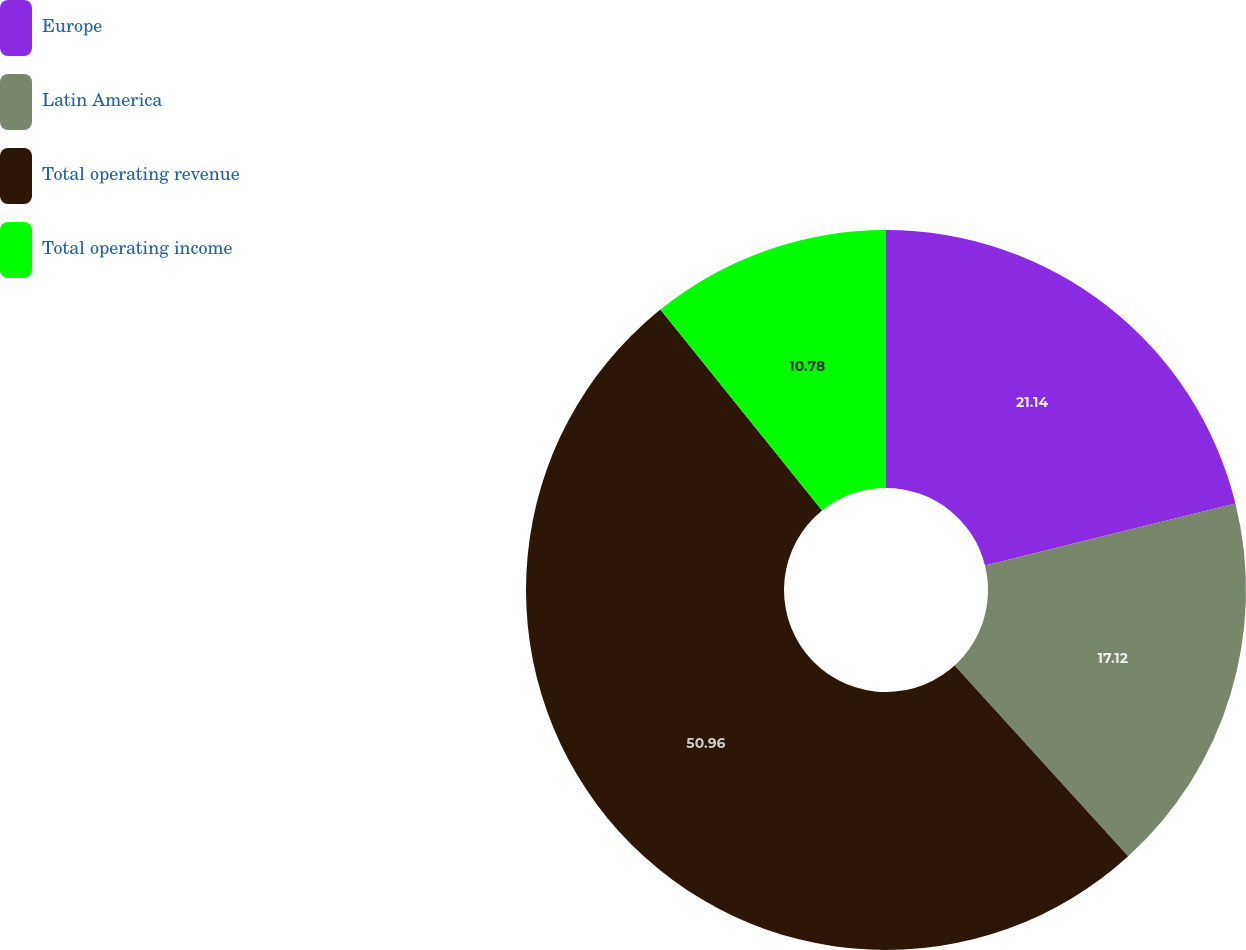Convert chart to OTSL. <chart><loc_0><loc_0><loc_500><loc_500><pie_chart><fcel>Europe<fcel>Latin America<fcel>Total operating revenue<fcel>Total operating income<nl><fcel>21.14%<fcel>17.12%<fcel>50.97%<fcel>10.78%<nl></chart> 